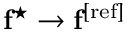Convert formula to latex. <formula><loc_0><loc_0><loc_500><loc_500>f ^ { ^ { * } } \rightarrow f ^ { [ r e f ] }</formula> 